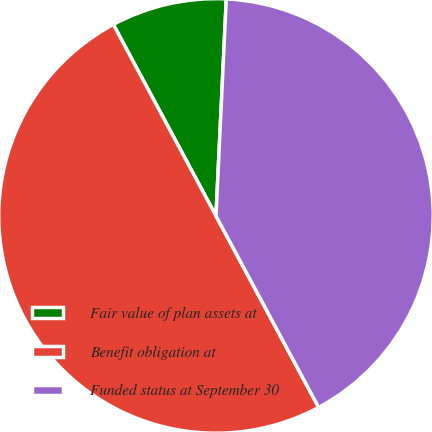<chart> <loc_0><loc_0><loc_500><loc_500><pie_chart><fcel>Fair value of plan assets at<fcel>Benefit obligation at<fcel>Funded status at September 30<nl><fcel>8.59%<fcel>50.0%<fcel>41.41%<nl></chart> 